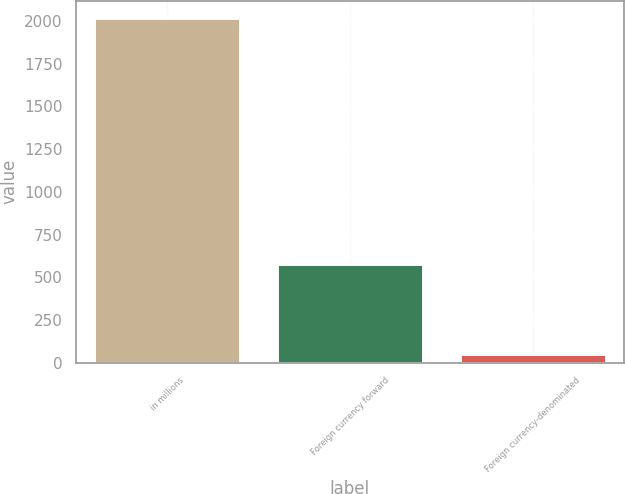Convert chart. <chart><loc_0><loc_0><loc_500><loc_500><bar_chart><fcel>in millions<fcel>Foreign currency forward<fcel>Foreign currency-denominated<nl><fcel>2018<fcel>577<fcel>50<nl></chart> 